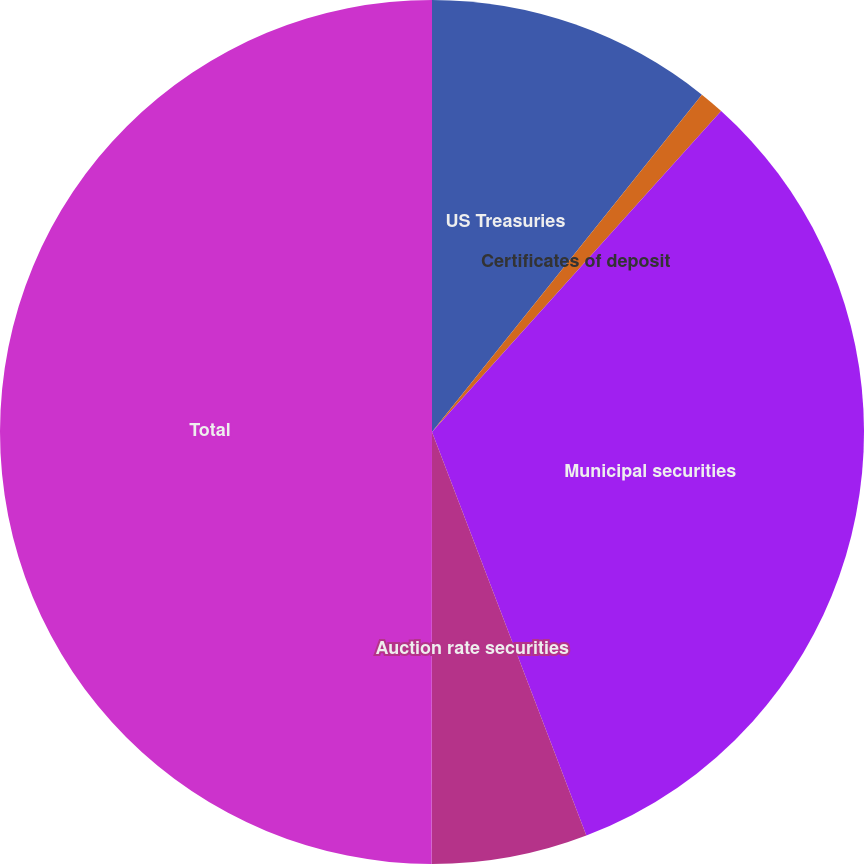Convert chart. <chart><loc_0><loc_0><loc_500><loc_500><pie_chart><fcel>US Treasuries<fcel>Certificates of deposit<fcel>Municipal securities<fcel>Auction rate securities<fcel>Total<nl><fcel>10.74%<fcel>0.93%<fcel>32.51%<fcel>5.83%<fcel>49.98%<nl></chart> 